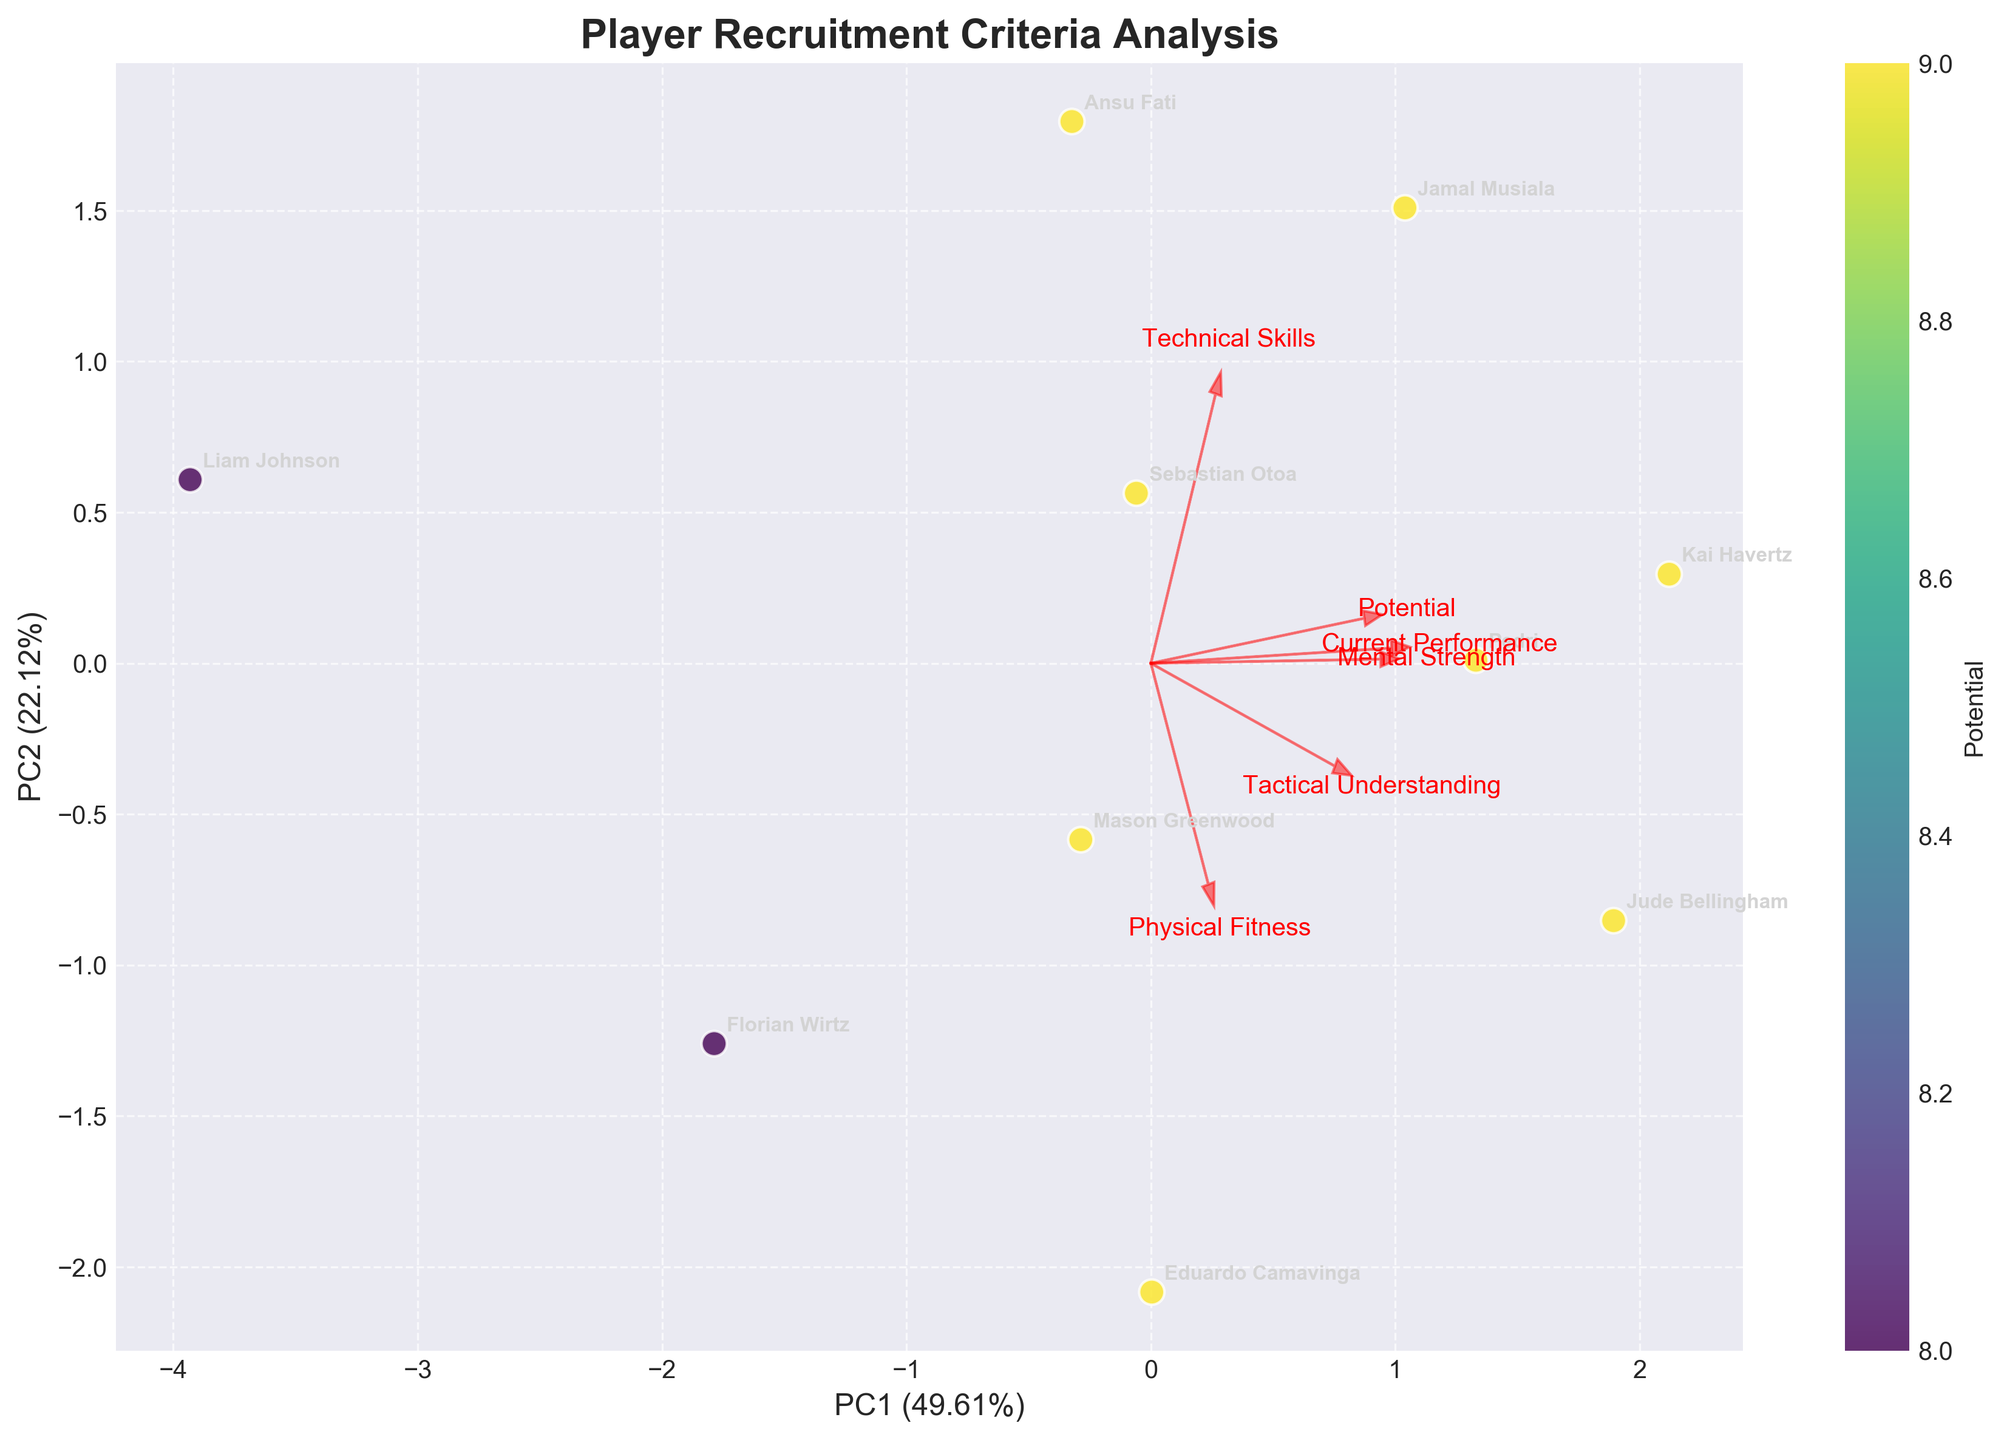How many players are displayed in the biplot? There are 10 players listed in the data used to generate the plot, and each player is represented as a data point on the biplot.
Answer: 10 What are the axes labels in the biplot? The x-axis is labeled "PC1" and the y-axis is labeled "PC2". Both indicate the percentage of the total variance explained by each principal component.
Answer: PC1 and PC2 Which player has the highest current performance according to the color gradient? The color gradient represents the player's potential. Kai Havertz, Jamal Musiala, Pedri, and Jude Bellingham are all shown in a similar shade indicating a potential of 9. Among them, Kai Havertz has the highest current performance with a score of 8.
Answer: Kai Havertz What relationship between current performance and potential can be observed from Sebastian Otoa's data point on the biplot? From Sebastian Otoa's data point, we see it is in the middle of the plot, indicating a high potential score. Its position signifies a close clustering with other high potential players despite slightly lower current performance.
Answer: High potential, mid-range current performance Which feature contributes the most to PC1 (the x-axis)? To determine which feature contributes the most to PC1, observe the arrows representing each feature. The feature with the longest arrow on the x-axis has the largest contribution. The "Technical Skills" feature has an arrow extending further along the x-axis than others, suggesting it has the most influence on PC1.
Answer: Technical Skills Among all players, who are closely located on the biplot relative to Sebastian Otoa? On the biplot, Sebastian Otoa is closely located near Mason Greenwood and Eduardo Camavinga, indicated by the proximity of their data points.
Answer: Mason Greenwood, Eduardo Camavinga 